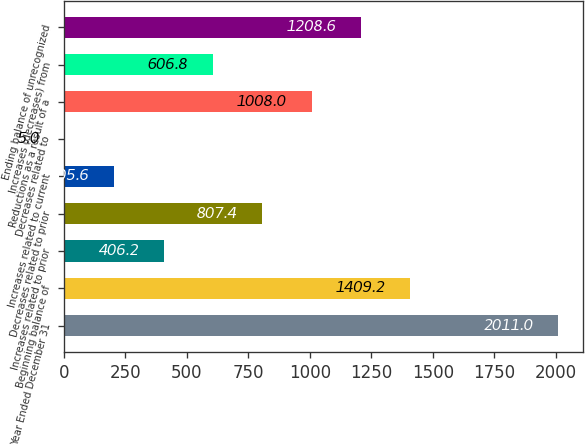Convert chart to OTSL. <chart><loc_0><loc_0><loc_500><loc_500><bar_chart><fcel>Year Ended December 31<fcel>Beginning balance of<fcel>Increases related to prior<fcel>Decreases related to prior<fcel>Increases related to current<fcel>Decreases related to<fcel>Reductions as a result of a<fcel>Increases (decreases) from<fcel>Ending balance of unrecognized<nl><fcel>2011<fcel>1409.2<fcel>406.2<fcel>807.4<fcel>205.6<fcel>5<fcel>1008<fcel>606.8<fcel>1208.6<nl></chart> 